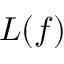Convert formula to latex. <formula><loc_0><loc_0><loc_500><loc_500>L ( f )</formula> 